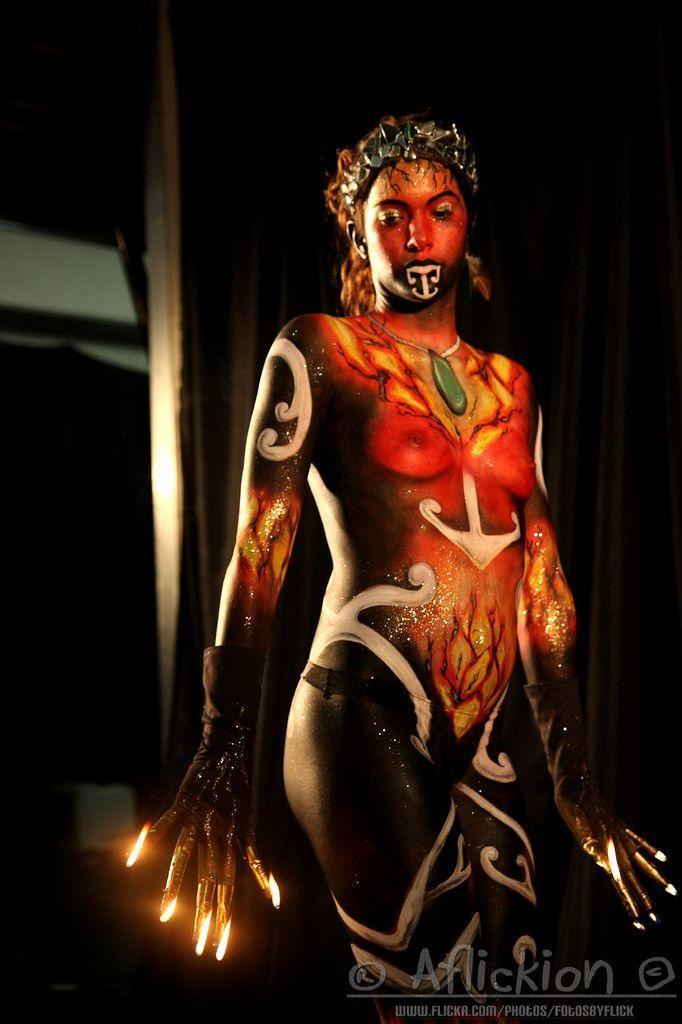How would you summarize this image in a sentence or two? In this image we can see a lady and on her we can see different type of painting. In the foreground of the image we can see a text. 